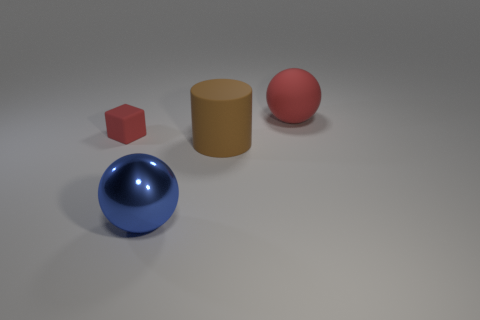Add 1 blue balls. How many objects exist? 5 Subtract all cubes. How many objects are left? 3 Subtract all big brown metal things. Subtract all matte cylinders. How many objects are left? 3 Add 4 big brown cylinders. How many big brown cylinders are left? 5 Add 3 tiny things. How many tiny things exist? 4 Subtract 0 blue cylinders. How many objects are left? 4 